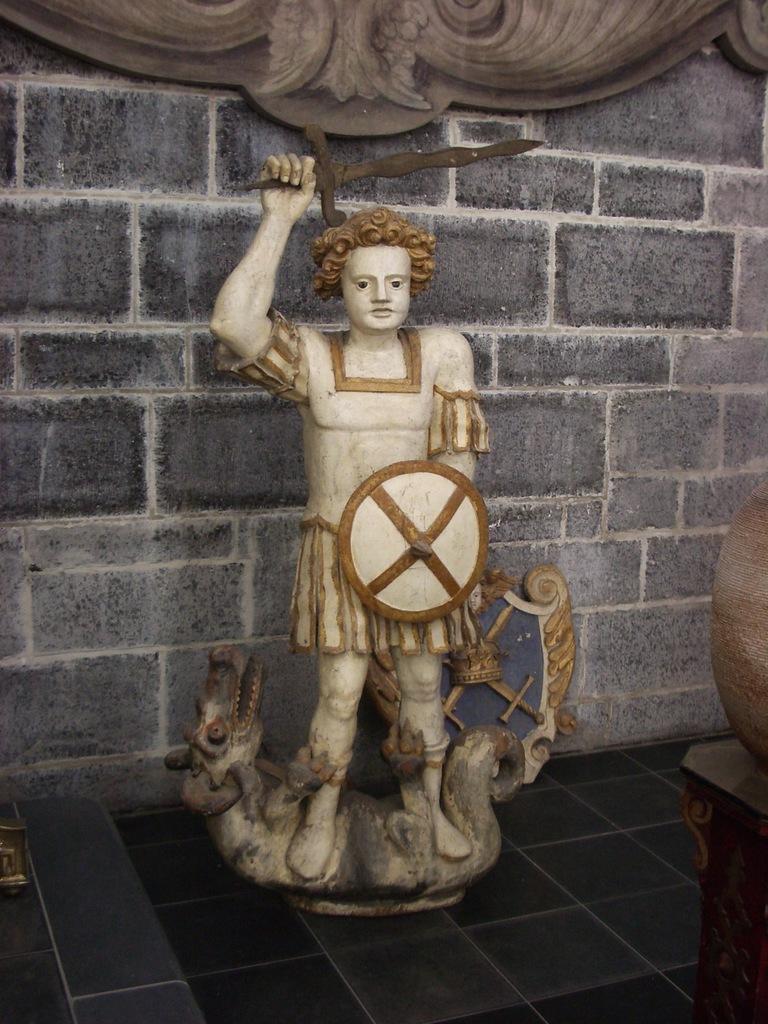What is the main subject in the center of the image? There is a statue in the center of the image. What can be seen in the background of the image? There is a wall in the background of the image. What type of advertisement is displayed on the statue in the image? There is no advertisement displayed on the statue in the image; it is a standalone statue. How many people are joining hands around the statue in the image? There are no people present in the image, so it is not possible to determine if anyone is joining hands around the statue. 